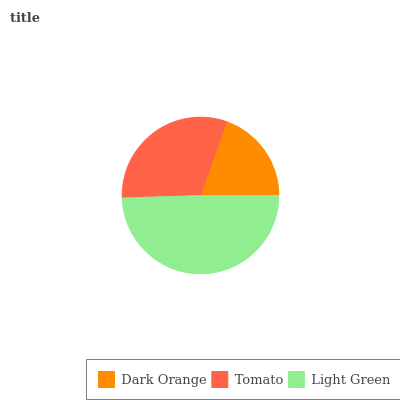Is Dark Orange the minimum?
Answer yes or no. Yes. Is Light Green the maximum?
Answer yes or no. Yes. Is Tomato the minimum?
Answer yes or no. No. Is Tomato the maximum?
Answer yes or no. No. Is Tomato greater than Dark Orange?
Answer yes or no. Yes. Is Dark Orange less than Tomato?
Answer yes or no. Yes. Is Dark Orange greater than Tomato?
Answer yes or no. No. Is Tomato less than Dark Orange?
Answer yes or no. No. Is Tomato the high median?
Answer yes or no. Yes. Is Tomato the low median?
Answer yes or no. Yes. Is Light Green the high median?
Answer yes or no. No. Is Dark Orange the low median?
Answer yes or no. No. 